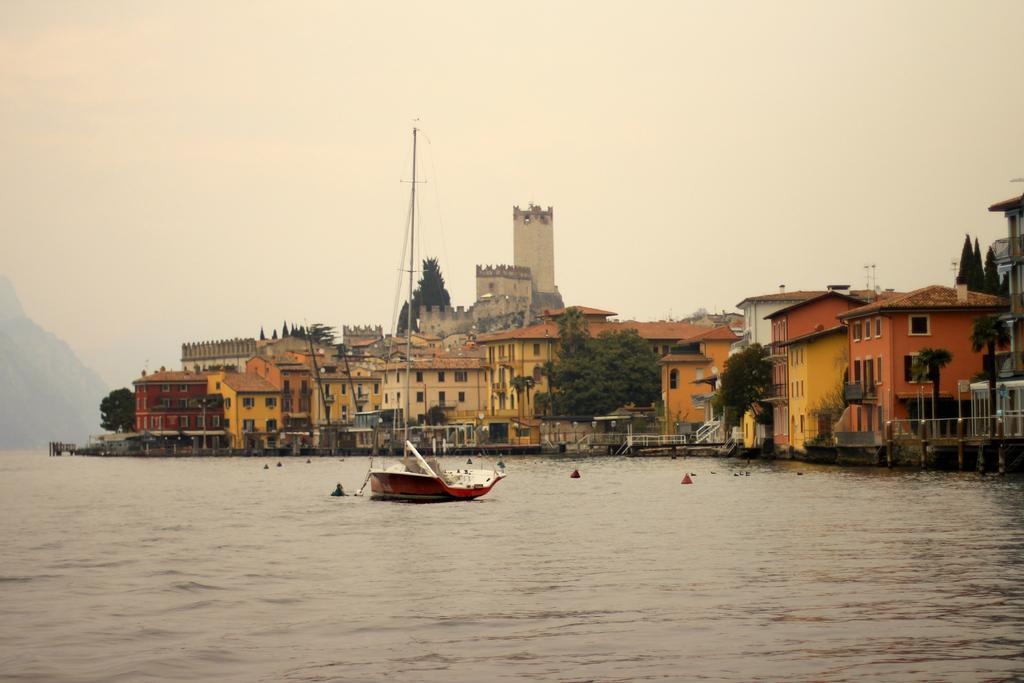Describe this image in one or two sentences. There is a boat with pole and ropes is on the water. In the background there are trees and buildings with windows. Also there is sky. 